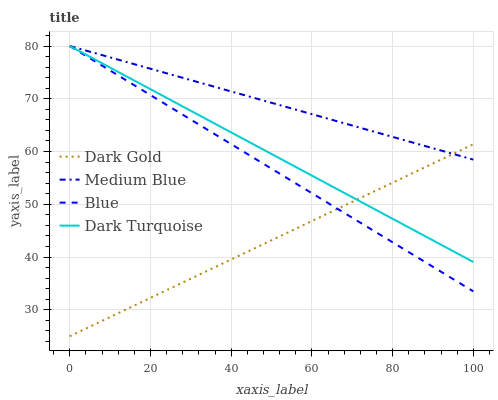Does Dark Gold have the minimum area under the curve?
Answer yes or no. Yes. Does Medium Blue have the maximum area under the curve?
Answer yes or no. Yes. Does Dark Turquoise have the minimum area under the curve?
Answer yes or no. No. Does Dark Turquoise have the maximum area under the curve?
Answer yes or no. No. Is Medium Blue the smoothest?
Answer yes or no. Yes. Is Dark Turquoise the roughest?
Answer yes or no. Yes. Is Dark Turquoise the smoothest?
Answer yes or no. No. Is Medium Blue the roughest?
Answer yes or no. No. Does Dark Gold have the lowest value?
Answer yes or no. Yes. Does Dark Turquoise have the lowest value?
Answer yes or no. No. Does Medium Blue have the highest value?
Answer yes or no. Yes. Does Dark Gold have the highest value?
Answer yes or no. No. Does Dark Turquoise intersect Medium Blue?
Answer yes or no. Yes. Is Dark Turquoise less than Medium Blue?
Answer yes or no. No. Is Dark Turquoise greater than Medium Blue?
Answer yes or no. No. 